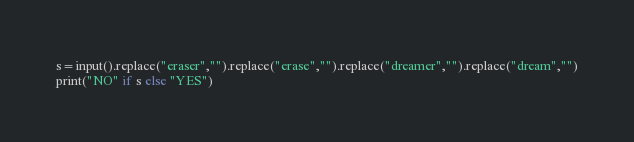<code> <loc_0><loc_0><loc_500><loc_500><_Python_>s=input().replace("eraser","").replace("erase","").replace("dreamer","").replace("dream","")
print("NO" if s else "YES")</code> 